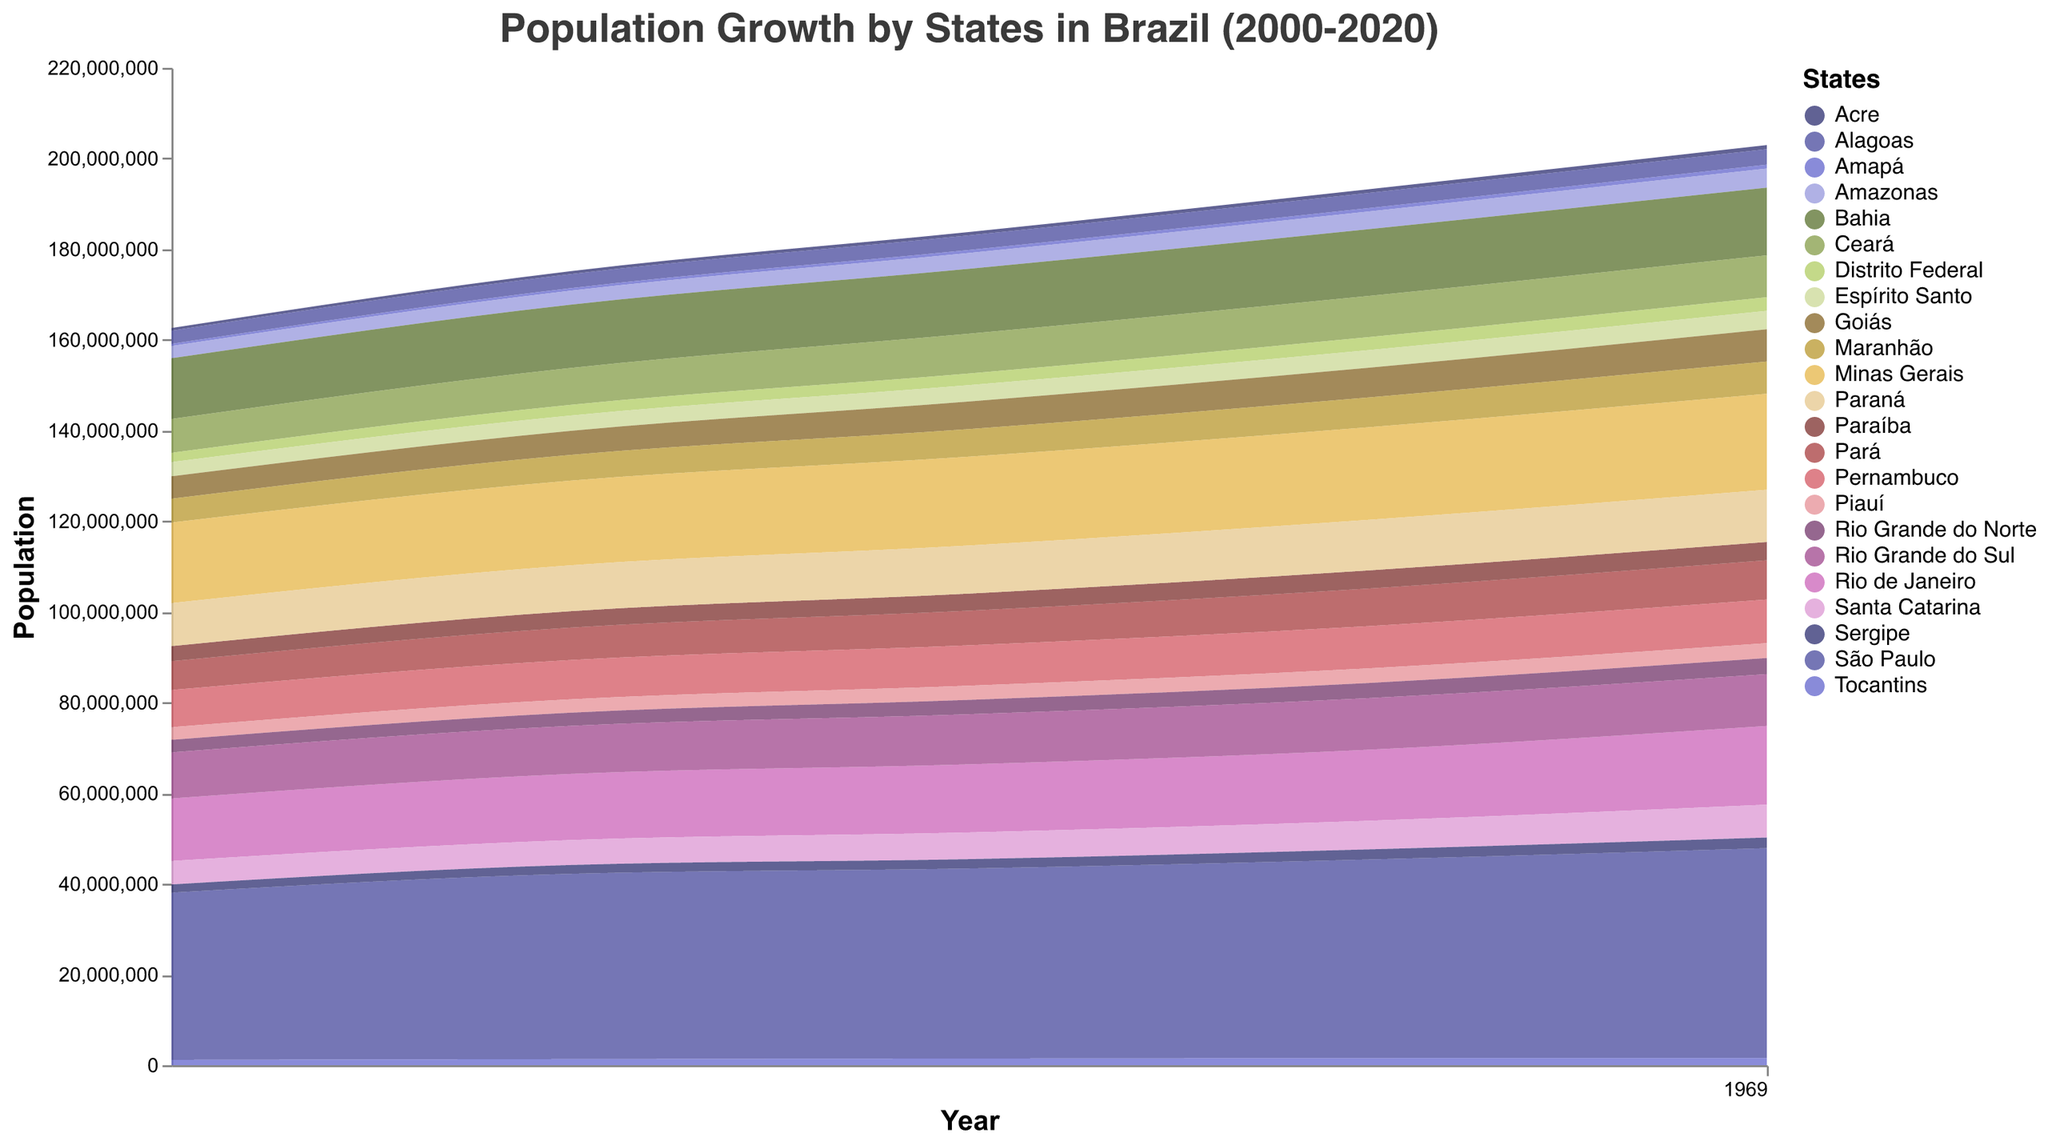What is the title of the chart? The title is displayed at the top of the figure, showing what the chart is about.
Answer: Population Growth by States in Brazil (2000-2020) Which state had the highest population in 2020? By looking at the heights of the stacked areas at the year 2020, the state with the highest population is identified by the region that extends the highest on the y-axis.
Answer: São Paulo What was the approximate population of Bahia in 2010? Find Bahia in the color legend on the right, then follow the corresponding colored area to the year 2010 and see its value on the y-axis.
Answer: Approximately 14.3 million Which state showed the most significant growth between 2000 and 2020? Compare the start and end points of each state's colored area and identify the one with the greatest vertical change on the y-axis from 2000 to 2020.
Answer: São Paulo How did the population of Amazonas change from 2000 to 2020? Locate Amazonas in the legend, then trace its colored area from 2000 to 2020 and note the change in height. Identify the population values for both years, and calculate the difference.
Answer: Increased by approximately 1.5 million Which states have similar population growth trends? Compare the shapes and slopes of different colored areas between 2000 and 2020 to find states with similar patterns or trajectories.
Answer: Rio Grande do Sul and Santa Catarina Comparing Acre and Distrito Federal, which had a greater population increase between 2000 and 2020? Find both states in the legend, trace their colored areas from 2000 to 2020, and compare the differences in the heights of their areas over the years.
Answer: Distrito Federal What was the population of Rio de Janeiro in 2005 and 2015? Locate Rio de Janeiro in the legend, then follow its colored area to the years 2005 and 2015 and note the population values.
Answer: Approximately 14.6 million (2005), 15.7 million (2015) Which state had the least population in 2020? Look for the colored area with the smallest height in 2020, indicating the lowest population. Trace this area back to the legend to identify the state.
Answer: Amapá 